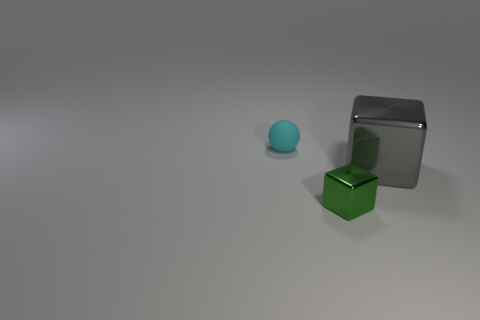There is a small thing that is in front of the rubber object; does it have the same shape as the shiny object that is right of the tiny metal block?
Provide a short and direct response. Yes. How many objects are tiny objects or blue matte spheres?
Give a very brief answer. 2. There is another object that is the same shape as the big gray metallic object; what size is it?
Your answer should be very brief. Small. Is the number of blocks left of the big block greater than the number of large red matte things?
Give a very brief answer. Yes. Is the material of the big gray object the same as the small cyan ball?
Ensure brevity in your answer.  No. What number of objects are either objects that are behind the green metal cube or objects that are behind the gray object?
Your answer should be very brief. 2. The other object that is the same shape as the tiny metal thing is what color?
Offer a terse response. Gray. What number of objects are objects that are on the right side of the tiny rubber sphere or big yellow spheres?
Ensure brevity in your answer.  2. What color is the thing behind the shiny thing that is right of the tiny thing in front of the tiny rubber sphere?
Provide a short and direct response. Cyan. There is a big thing that is made of the same material as the tiny cube; what color is it?
Offer a terse response. Gray. 